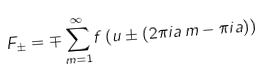<formula> <loc_0><loc_0><loc_500><loc_500>F _ { \pm } = \mp \sum _ { m = 1 } ^ { \infty } f \left ( u \pm ( 2 \pi i a \, m - \pi i a ) \right )</formula> 